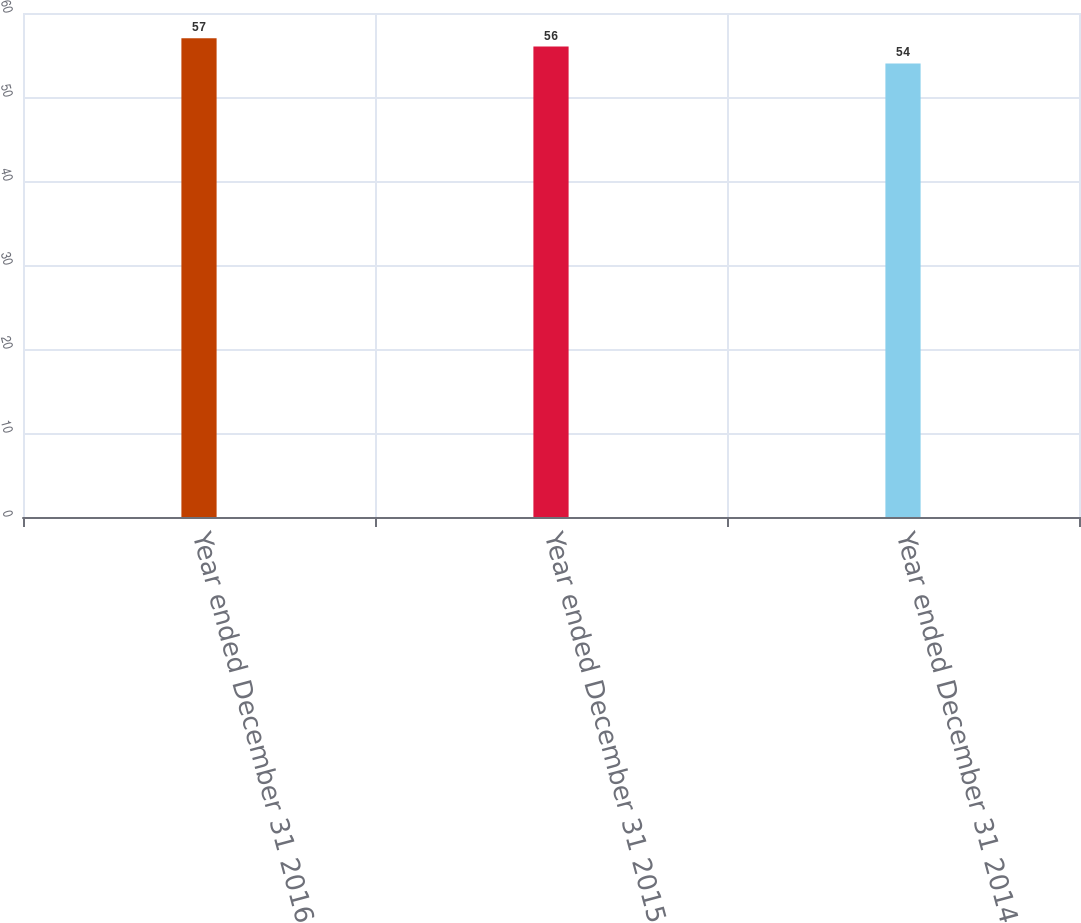<chart> <loc_0><loc_0><loc_500><loc_500><bar_chart><fcel>Year ended December 31 2016<fcel>Year ended December 31 2015<fcel>Year ended December 31 2014<nl><fcel>57<fcel>56<fcel>54<nl></chart> 